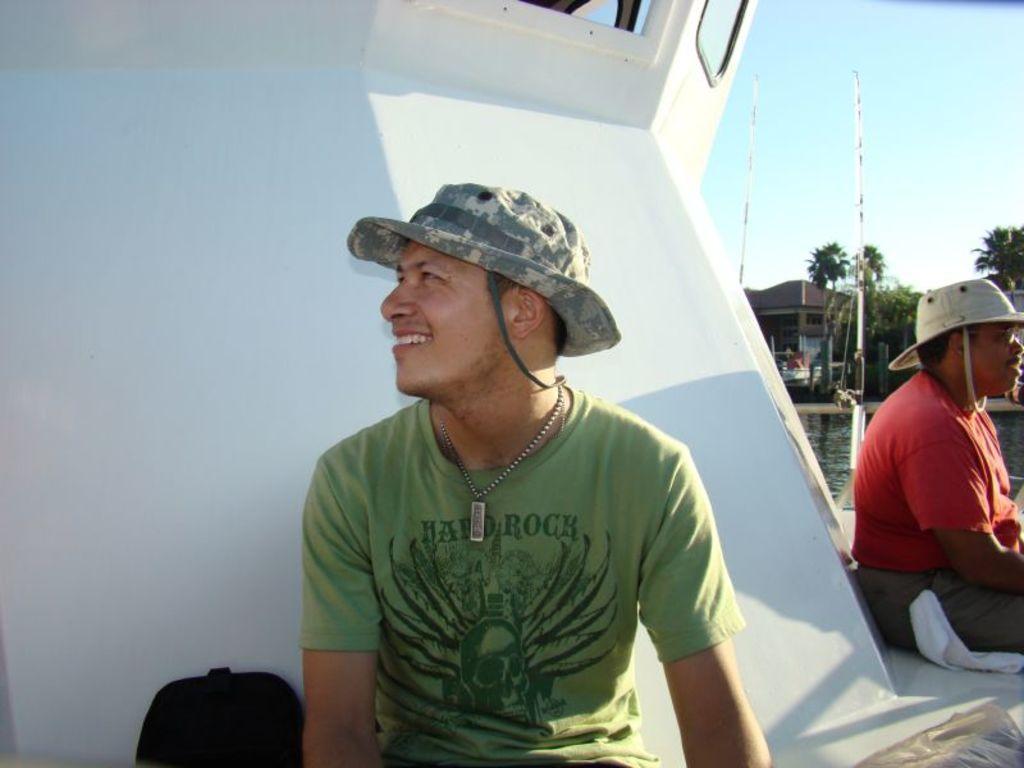How would you summarize this image in a sentence or two? In this image there are two people wearing hats and sitting on a ship, in the background there is water, trees, houses, pole and the sky. 